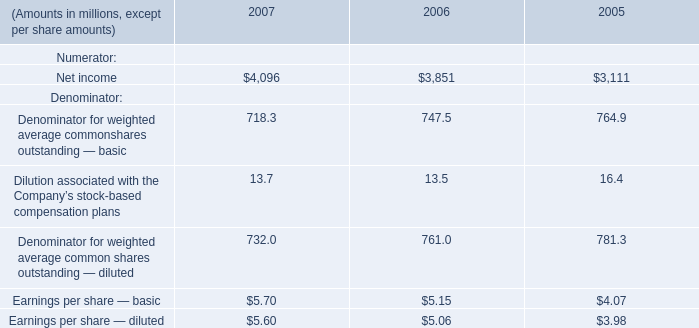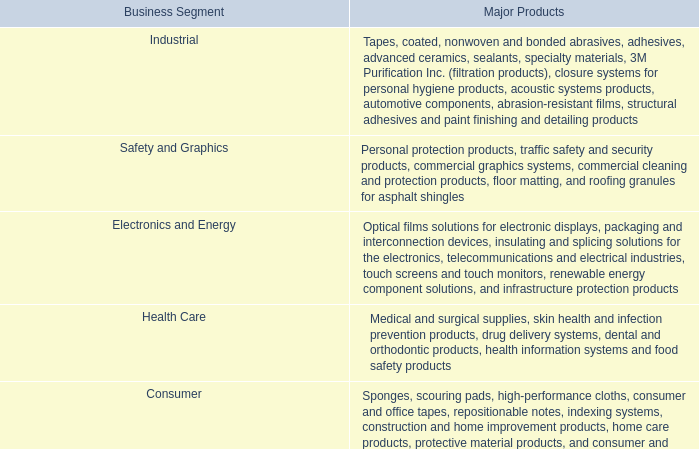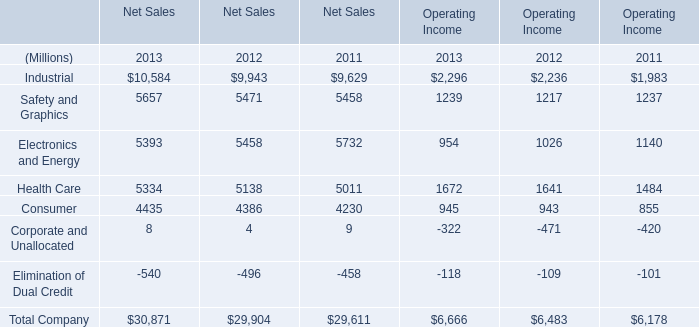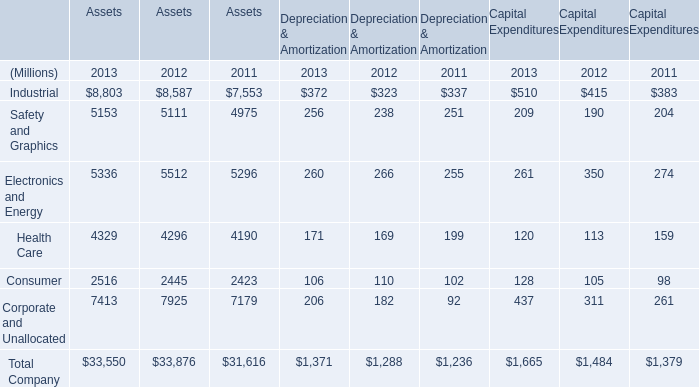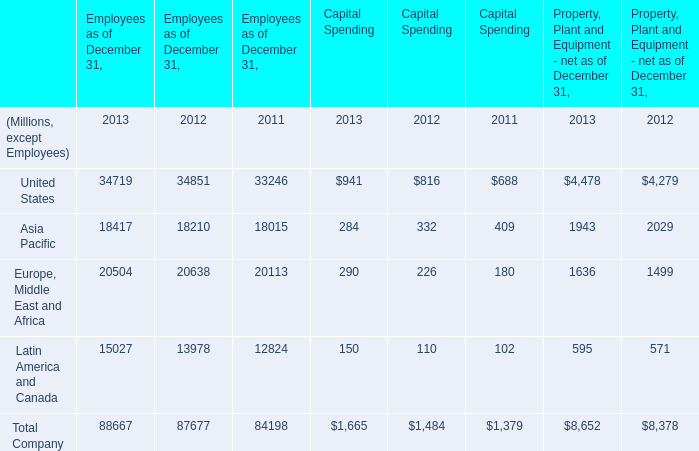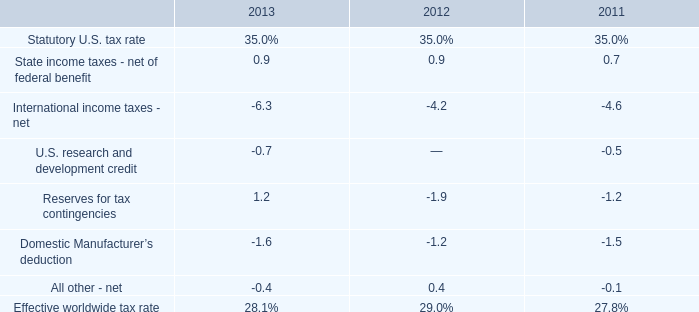What's the average of Safety and Graphics of Assets 2011, and Industrial of Operating Income 2012 ? 
Computations: ((4975.0 + 2236.0) / 2)
Answer: 3605.5. 